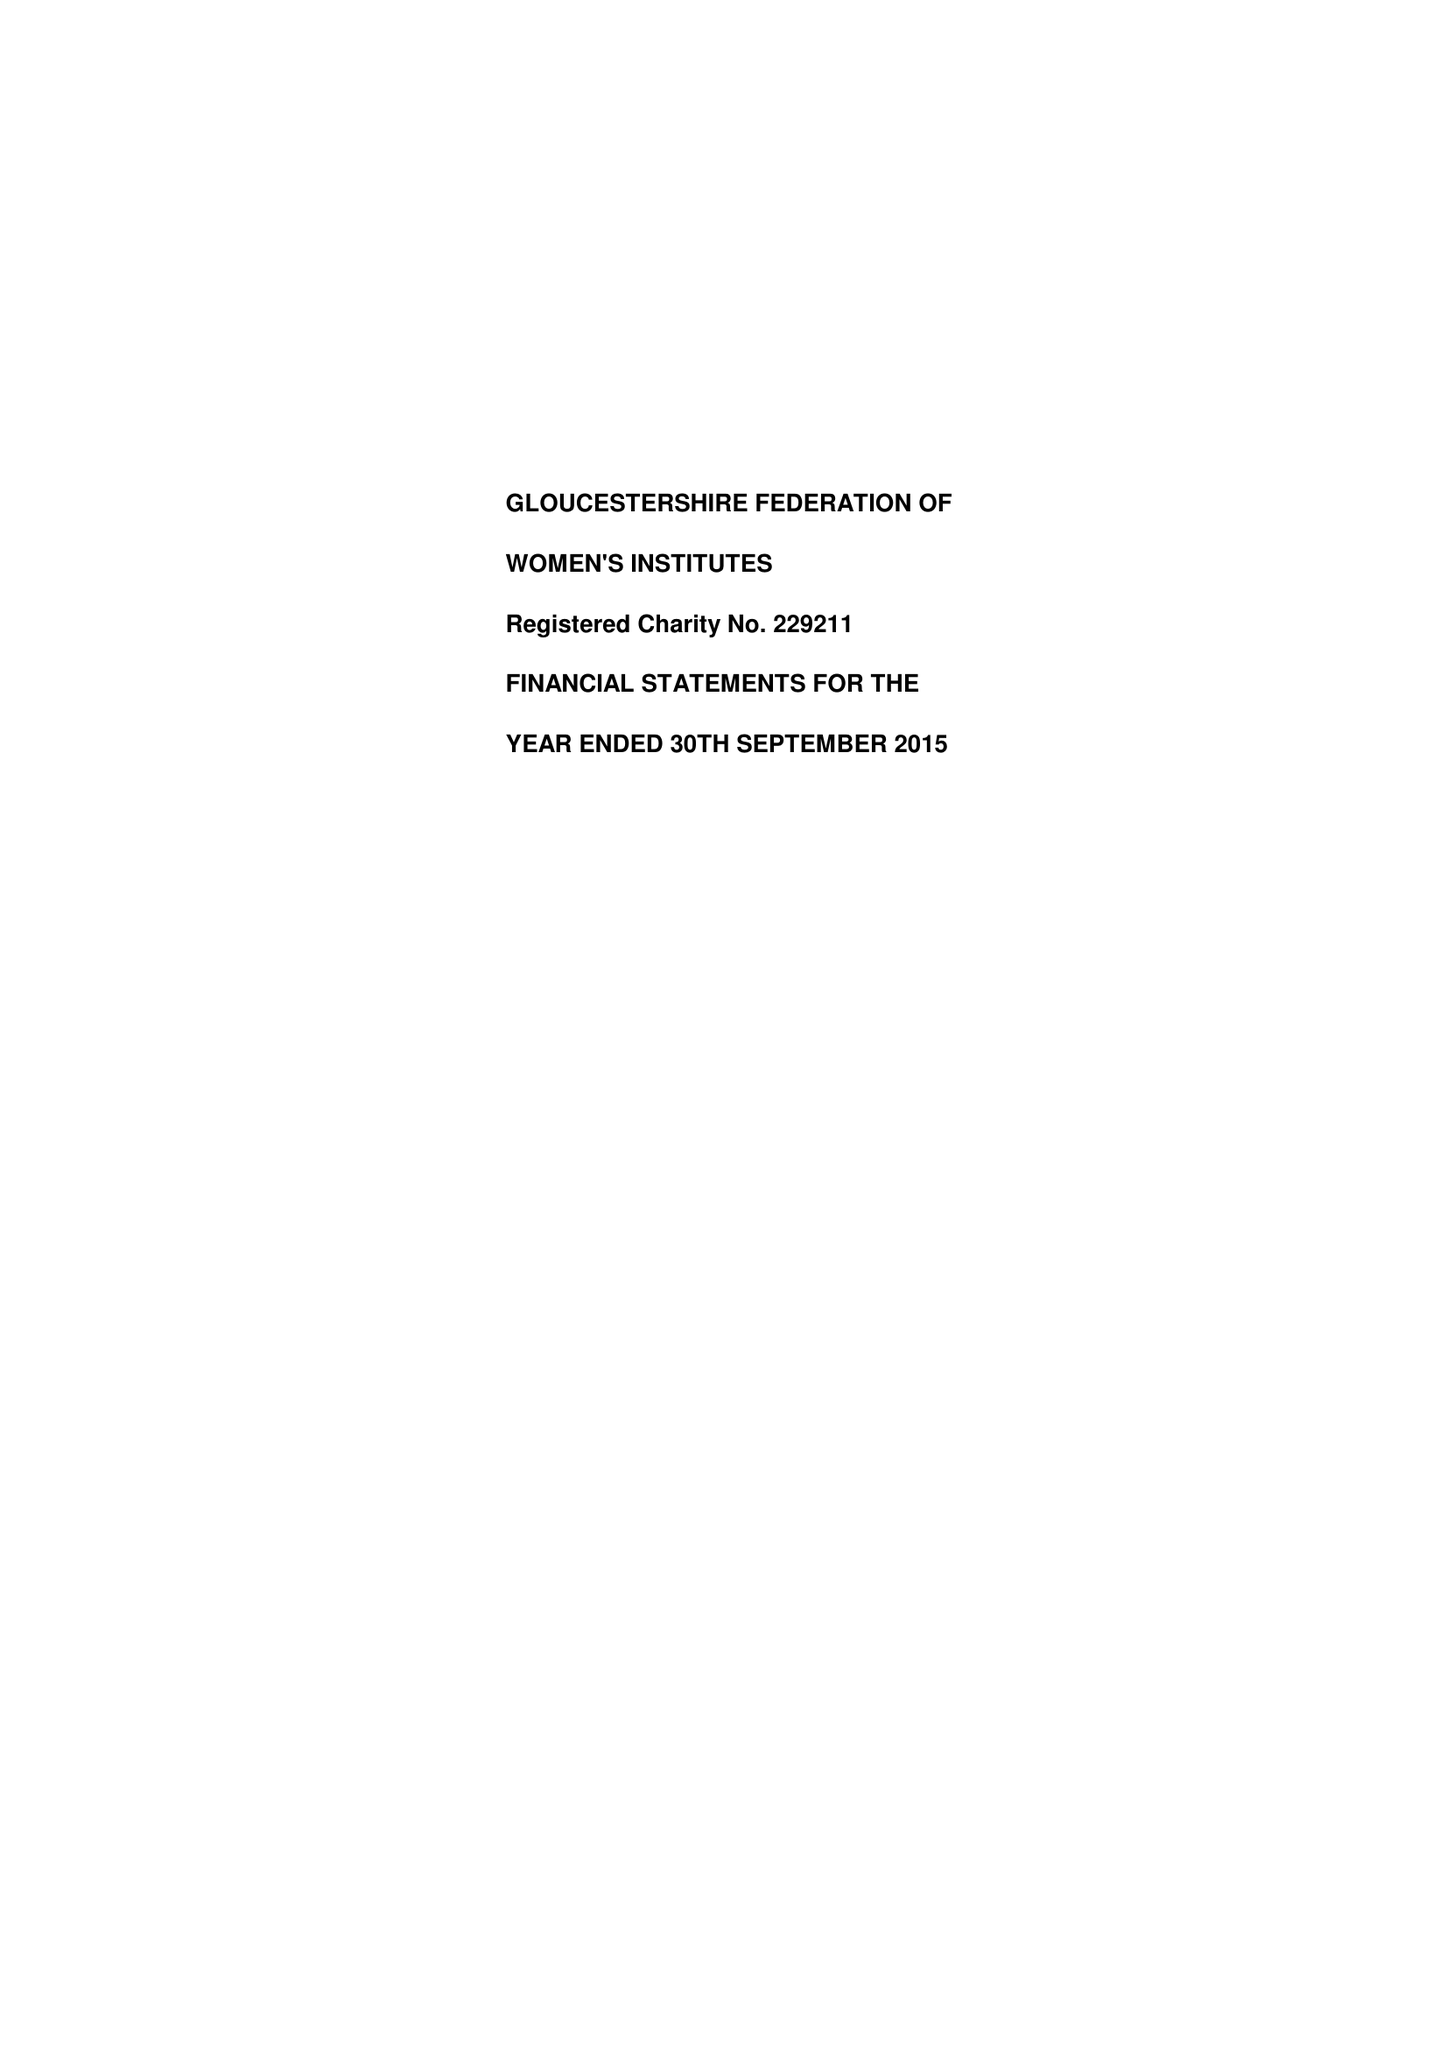What is the value for the income_annually_in_british_pounds?
Answer the question using a single word or phrase. 235701.00 